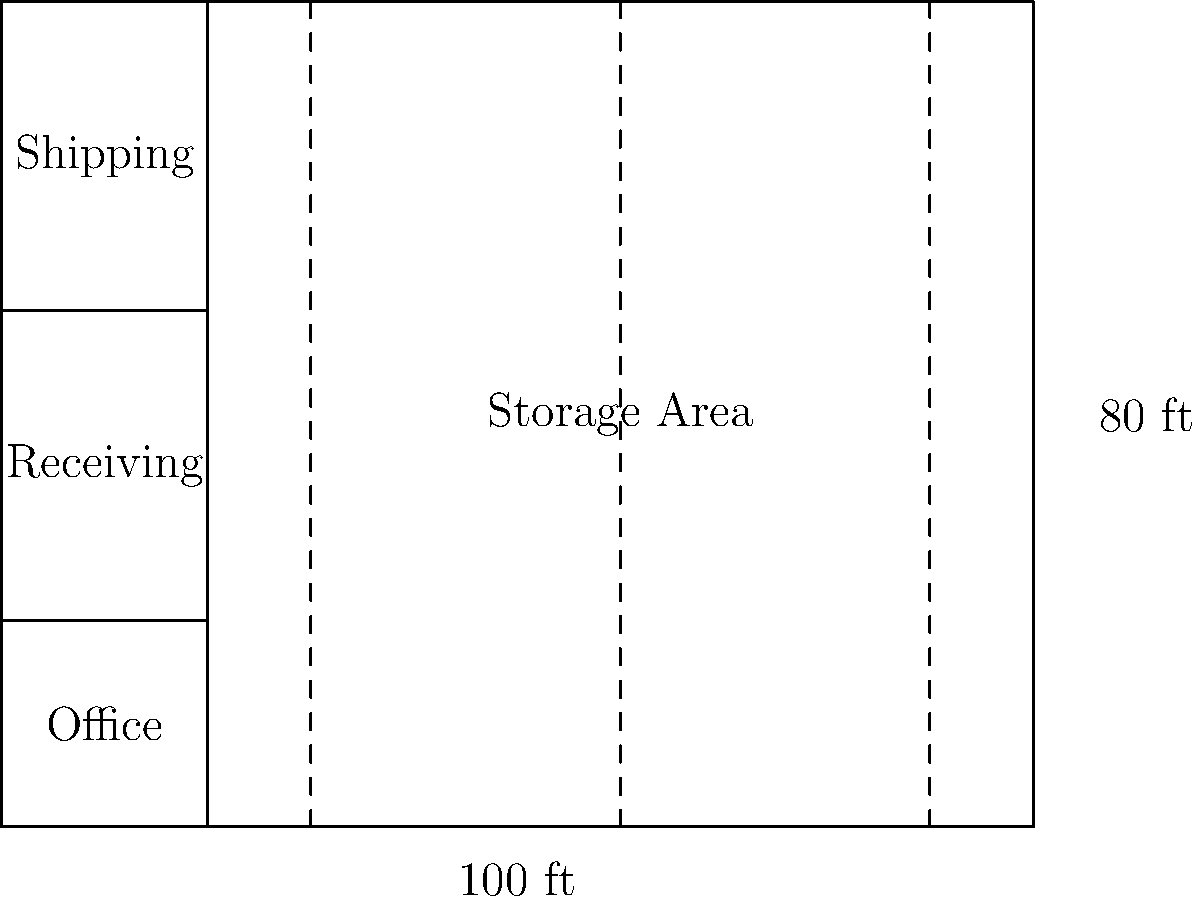In the given warehouse floor plan, what is the total percentage of floor space dedicated to the receiving and shipping areas combined? To solve this problem, we need to follow these steps:

1. Calculate the total area of the warehouse:
   Total area = length × width = 100 ft × 80 ft = 8000 sq ft

2. Calculate the area of the receiving area:
   Receiving area = length × width = 20 ft × 30 ft = 600 sq ft

3. Calculate the area of the shipping area:
   Shipping area = length × width = 20 ft × 30 ft = 600 sq ft

4. Calculate the combined area of receiving and shipping:
   Combined area = Receiving area + Shipping area = 600 sq ft + 600 sq ft = 1200 sq ft

5. Calculate the percentage of floor space dedicated to receiving and shipping:
   Percentage = (Combined area ÷ Total area) × 100
              = (1200 sq ft ÷ 8000 sq ft) × 100
              = 0.15 × 100 = 15%

Therefore, the total percentage of floor space dedicated to the receiving and shipping areas combined is 15%.
Answer: 15% 